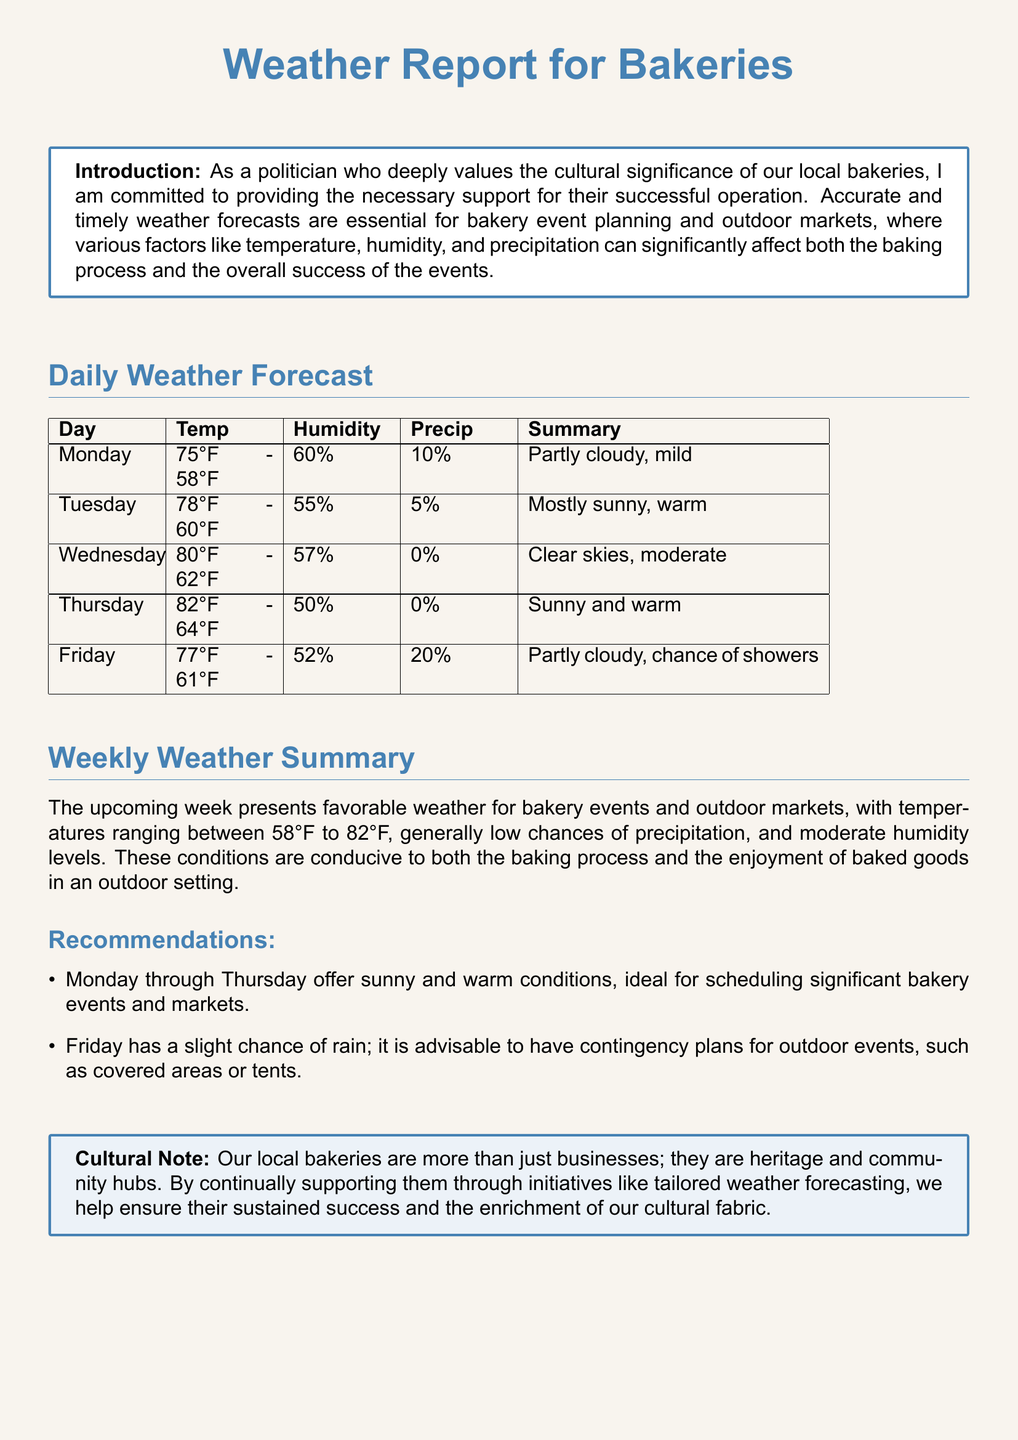What is the highest temperature forecasted for the week? The highest temperature for the week is listed in the daily forecast under Wednesday, which is 80°F.
Answer: 80°F What day has a chance of showers? The document specifies that Friday has a chance of showers with a 20% precipitation forecast.
Answer: Friday What is the humidity level on Thursday? The humidity level for Thursday is retrieved from the daily forecast table, listed as 50%.
Answer: 50% How many days have sunny conditions? The reasoning involves counting the days listed in the daily weather forecast that mention sunny conditions, which includes Tuesday, Wednesday, and Thursday, totaling three days.
Answer: 3 What is the recommended plan for Friday events? The recommendation for Friday advises having contingency plans in case of rain, which indicates the need for covered areas or tents.
Answer: Covered areas or tents What is the temperature range for the week? The temperature range for the week can be determined from the daily forecast, with the lowest being 58°F and the highest being 82°F.
Answer: 58°F to 82°F What is the overall weather summary for the week? The overall summary describes favorable weather for events, focusing on temperatures, low precipitation chances, and moderate humidity.
Answer: Favorable weather What is the cultural note about bakeries? The cultural note highlights the importance of local bakeries as heritage and community hubs, emphasizing their cultural significance.
Answer: Heritage and community hubs 